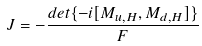Convert formula to latex. <formula><loc_0><loc_0><loc_500><loc_500>J = - \frac { d e t \{ - i [ { M } _ { u , H } , { M } _ { d , H } ] \} } { F }</formula> 